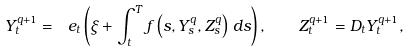Convert formula to latex. <formula><loc_0><loc_0><loc_500><loc_500>Y ^ { q + 1 } _ { t } = \ e _ { t } \left ( \xi + \int _ { t } ^ { T } f \left ( s , Y ^ { q } _ { s } , Z ^ { q } _ { s } \right ) \, d s \right ) , \quad Z ^ { q + 1 } _ { t } = D _ { t } Y ^ { q + 1 } _ { t } ,</formula> 